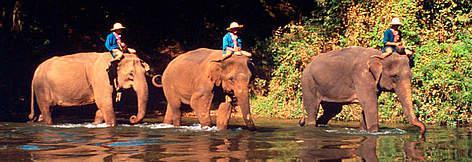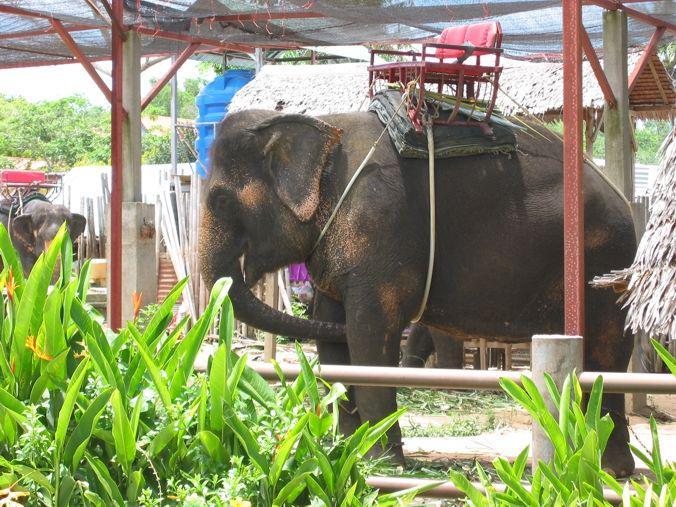The first image is the image on the left, the second image is the image on the right. Evaluate the accuracy of this statement regarding the images: "A leftward-facing elephant has a type of chair strapped to its back.". Is it true? Answer yes or no. Yes. The first image is the image on the left, the second image is the image on the right. Given the left and right images, does the statement "A person is riding an elephant that is wading through water." hold true? Answer yes or no. Yes. 